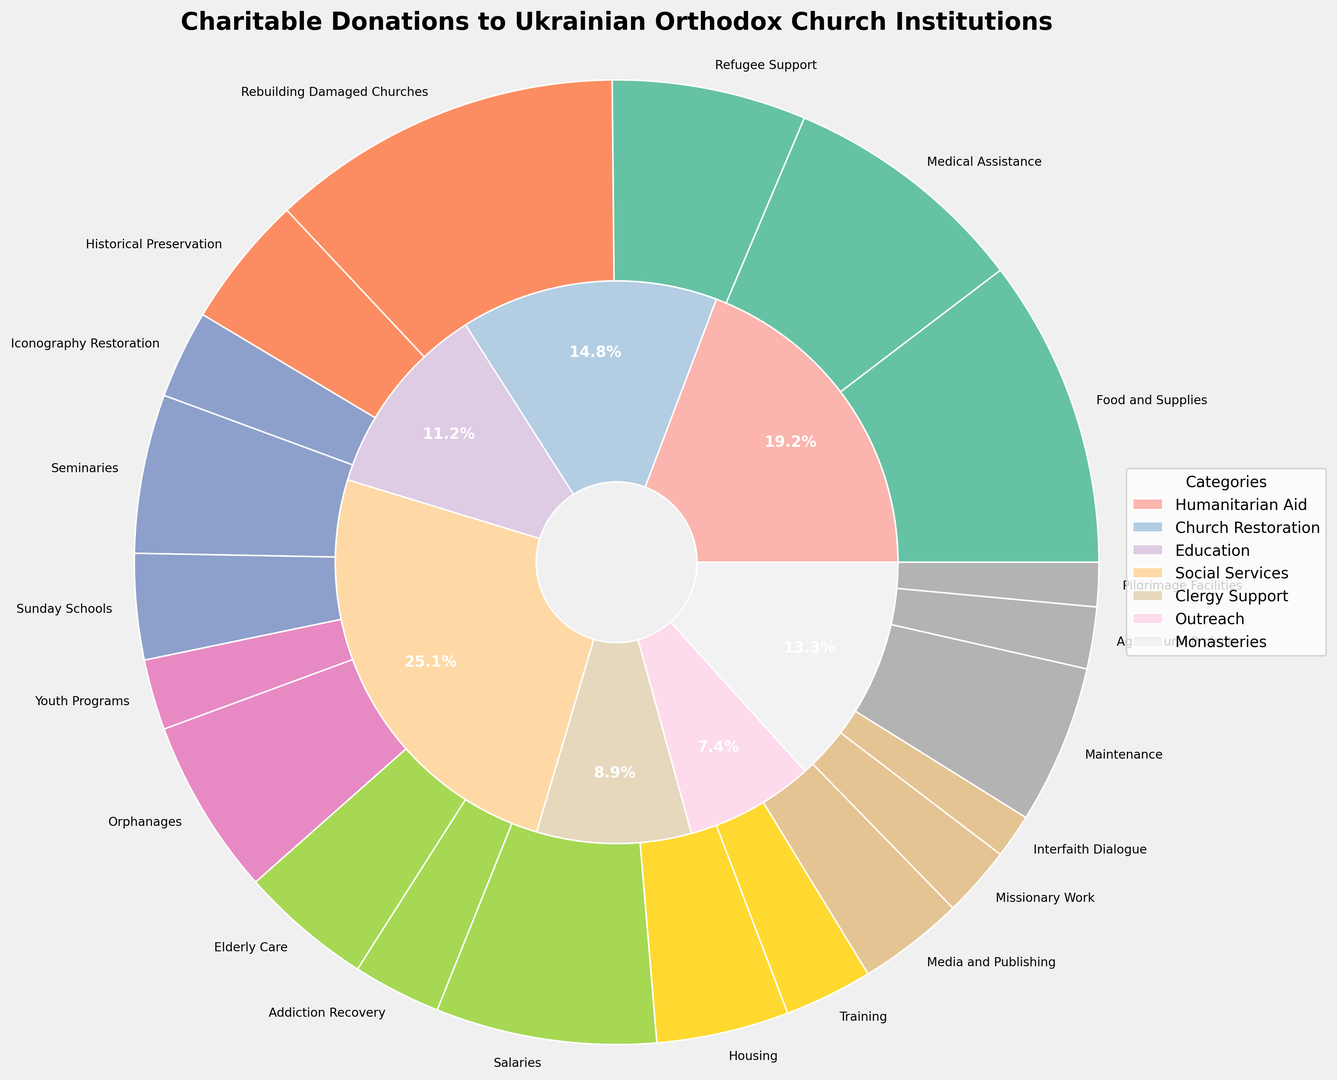What percentage of the total donations goes to Humanitarian Aid? To find the percentage of donations allocated to Humanitarian Aid, sum up the values of its subcategories: Food and Supplies (35), Medical Assistance (28), and Refugee Support (22), which gives a total of 85. Then, sum up the total donations for all categories: 35 + 28 + 22 + 40 + 15 + 10 + 18 + 12 + 8 + 20 + 15 + 10 + 25 + 15 + 10 + 12 + 8 + 5 + 18 + 7 + 5 = 328. Finally, divide the total for Humanitarian Aid by the overall total and multiply by 100: (85 / 328) * 100 ≈ 25.9%.
Answer: 25.9% Which category receives the highest individual subcategory donation, and what is the amount? Check the figure for subcategory values. Rebuilding Damaged Churches under Church Restoration has the highest individual donation at 40.
Answer: Church Restoration, 40 How much more is donated to Clergy Support compared to Outreach? Sum up the donations for Clergy Support: Salaries (25), Housing (15), and Training (10) gives a total of 50. Sum up the donations for Outreach: Media and Publishing (12), Missionary Work (8), and Interfaith Dialogue (5) gives a total of 25. The difference is 50 - 25 = 25.
Answer: 25 Which subcategory under Social Services receives the least funding? According to the figure, Addiction Recovery receives the smallest donation under Social Services at 10.
Answer: Addiction Recovery Rank the subcategories under Church Restoration by the amount of donation received. The subcategories under Church Restoration are: Rebuilding Damaged Churches (40), Historical Preservation (15), and Iconography Restoration (10). In descending order of donations: Rebuilding Damaged Churches (40), Historical Preservation (15), and Iconography Restoration (10).
Answer: Rebuilding Damaged Churches, Historical Preservation, Iconography Restoration Is the donation allocation for Youth Programs under Education greater than for Elderly Care under Social Services? According to the figure, donations for Youth Programs are 8 and for Elderly Care are 15. 8 is less than 15.
Answer: No What portion of the total donations is allocated to Monasteries, and how is it distributed among its subcategories? Sum up the donations for Monasteries: Maintenance (18), Agricultural Projects (7), and Pilgrimage Facilities (5) gives a total of 30. The total donations for all categories amount to 328 (as previously calculated). The portion allocated to Monasteries is (30 / 328) * 100 ≈ 9.1%. Distributions among subcategories: Maintenance (18), Agricultural Projects (7), Pilgrimage Facilities (5).
Answer: 9.1%, Maintenance (18), Agricultural Projects (7), Pilgrimage Facilities (5) Which category has the fewest subcategories, and what are they? The category with the fewest subcategories is Outreach, with three subcategories: Media and Publishing (12), Missionary Work (8), and Interfaith Dialogue (5).
Answer: Outreach, Media and Publishing, Missionary Work, Interfaith Dialogue 